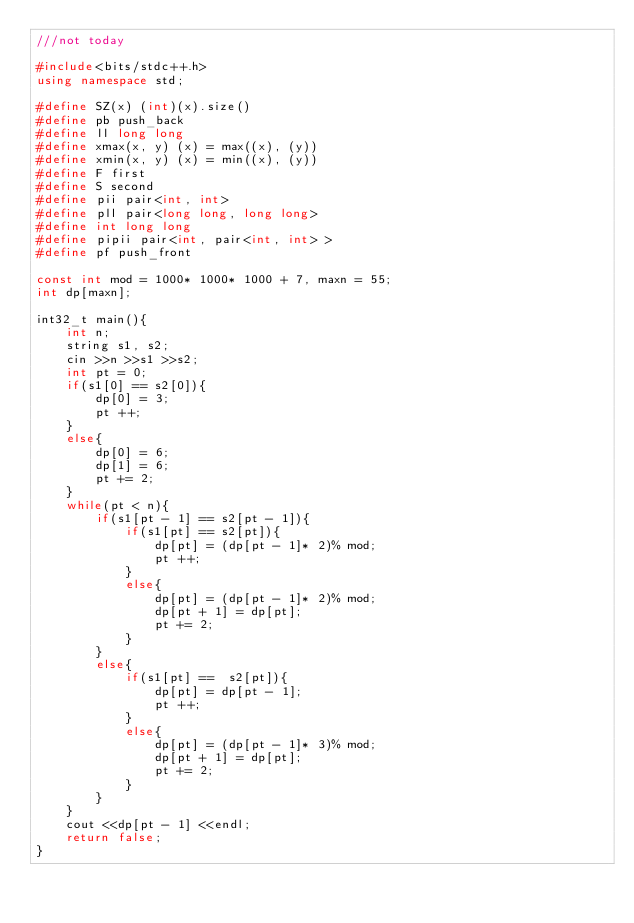<code> <loc_0><loc_0><loc_500><loc_500><_C++_>///not today

#include<bits/stdc++.h>
using namespace std;

#define SZ(x) (int)(x).size()
#define pb push_back
#define ll long long
#define xmax(x, y) (x) = max((x), (y))
#define xmin(x, y) (x) = min((x), (y))
#define F first
#define S second
#define pii pair<int, int>
#define pll pair<long long, long long>
#define int long long
#define pipii pair<int, pair<int, int> >
#define pf push_front

const int mod = 1000* 1000* 1000 + 7, maxn = 55;
int dp[maxn];

int32_t main(){
    int n;
    string s1, s2;
    cin >>n >>s1 >>s2;
    int pt = 0;
    if(s1[0] == s2[0]){
        dp[0] = 3;
        pt ++;
    }
    else{
        dp[0] = 6;
        dp[1] = 6;
        pt += 2;
    }
    while(pt < n){
        if(s1[pt - 1] == s2[pt - 1]){
            if(s1[pt] == s2[pt]){
                dp[pt] = (dp[pt - 1]* 2)% mod;
                pt ++;
            }
            else{
                dp[pt] = (dp[pt - 1]* 2)% mod;
                dp[pt + 1] = dp[pt];
                pt += 2;
            }
        }
        else{
            if(s1[pt] ==  s2[pt]){
                dp[pt] = dp[pt - 1];
                pt ++;
            }
            else{
                dp[pt] = (dp[pt - 1]* 3)% mod;
                dp[pt + 1] = dp[pt];
                pt += 2;
            }
        }
    }
    cout <<dp[pt - 1] <<endl;
    return false;
}
</code> 